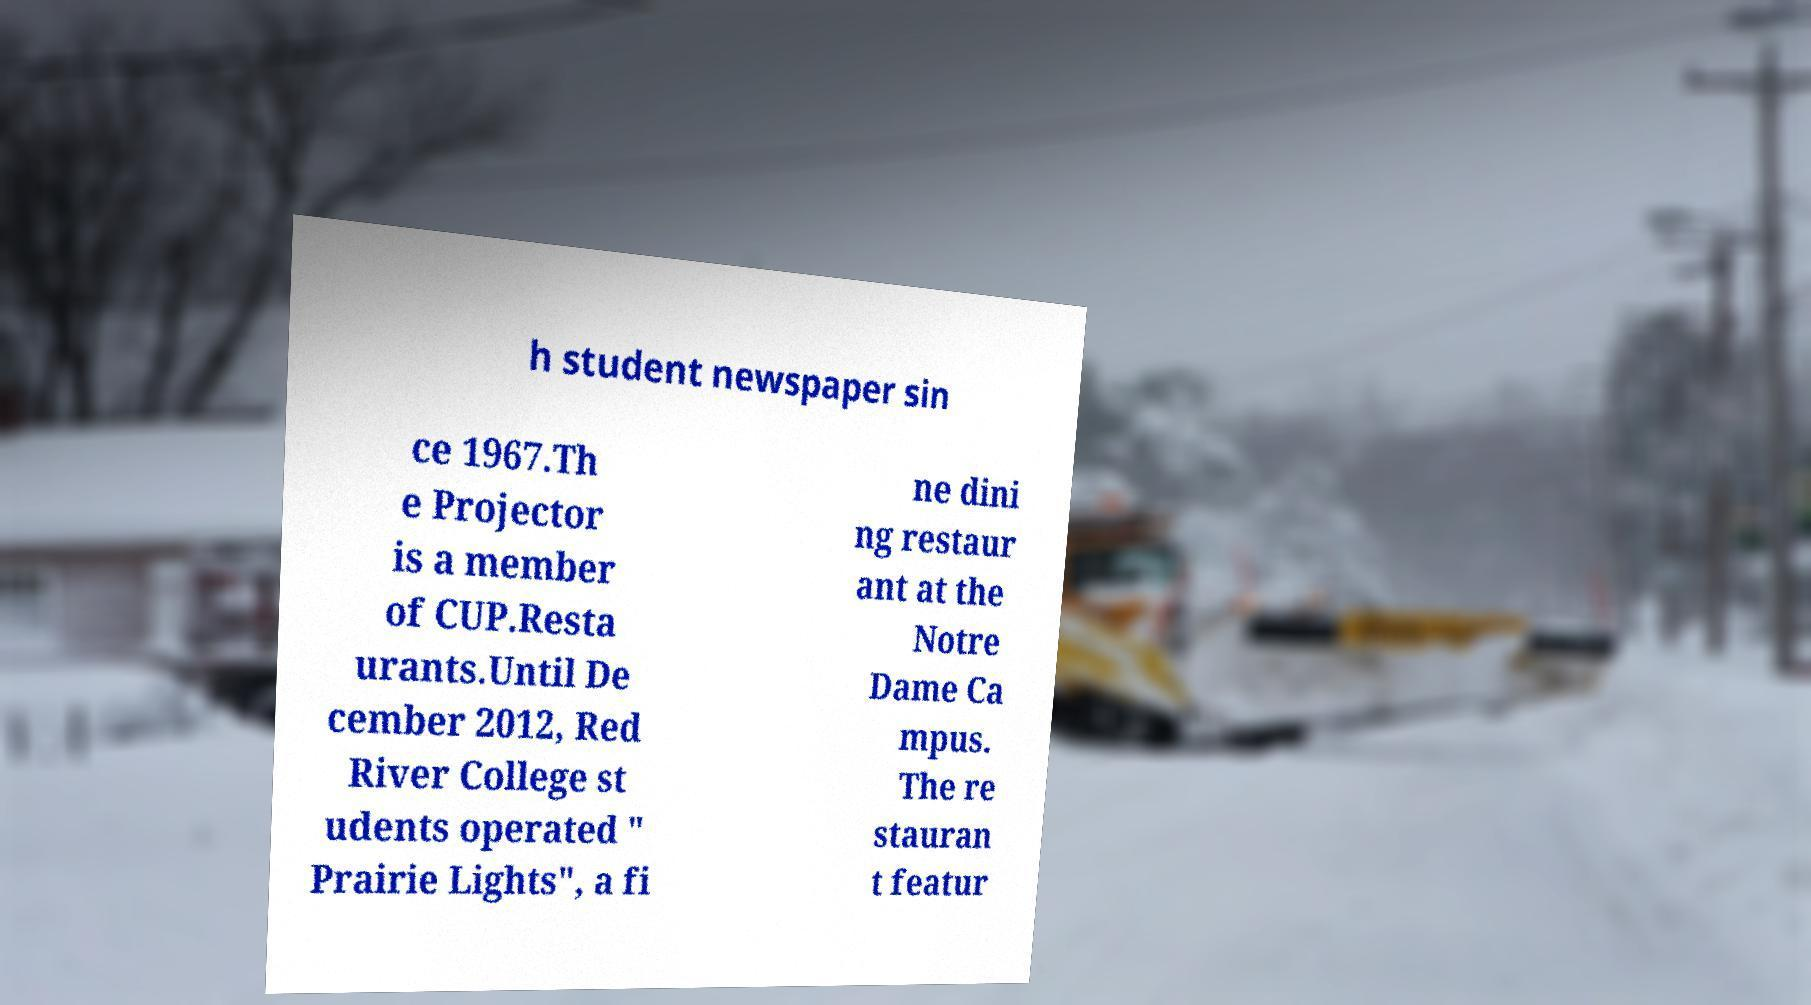Could you extract and type out the text from this image? h student newspaper sin ce 1967.Th e Projector is a member of CUP.Resta urants.Until De cember 2012, Red River College st udents operated " Prairie Lights", a fi ne dini ng restaur ant at the Notre Dame Ca mpus. The re stauran t featur 